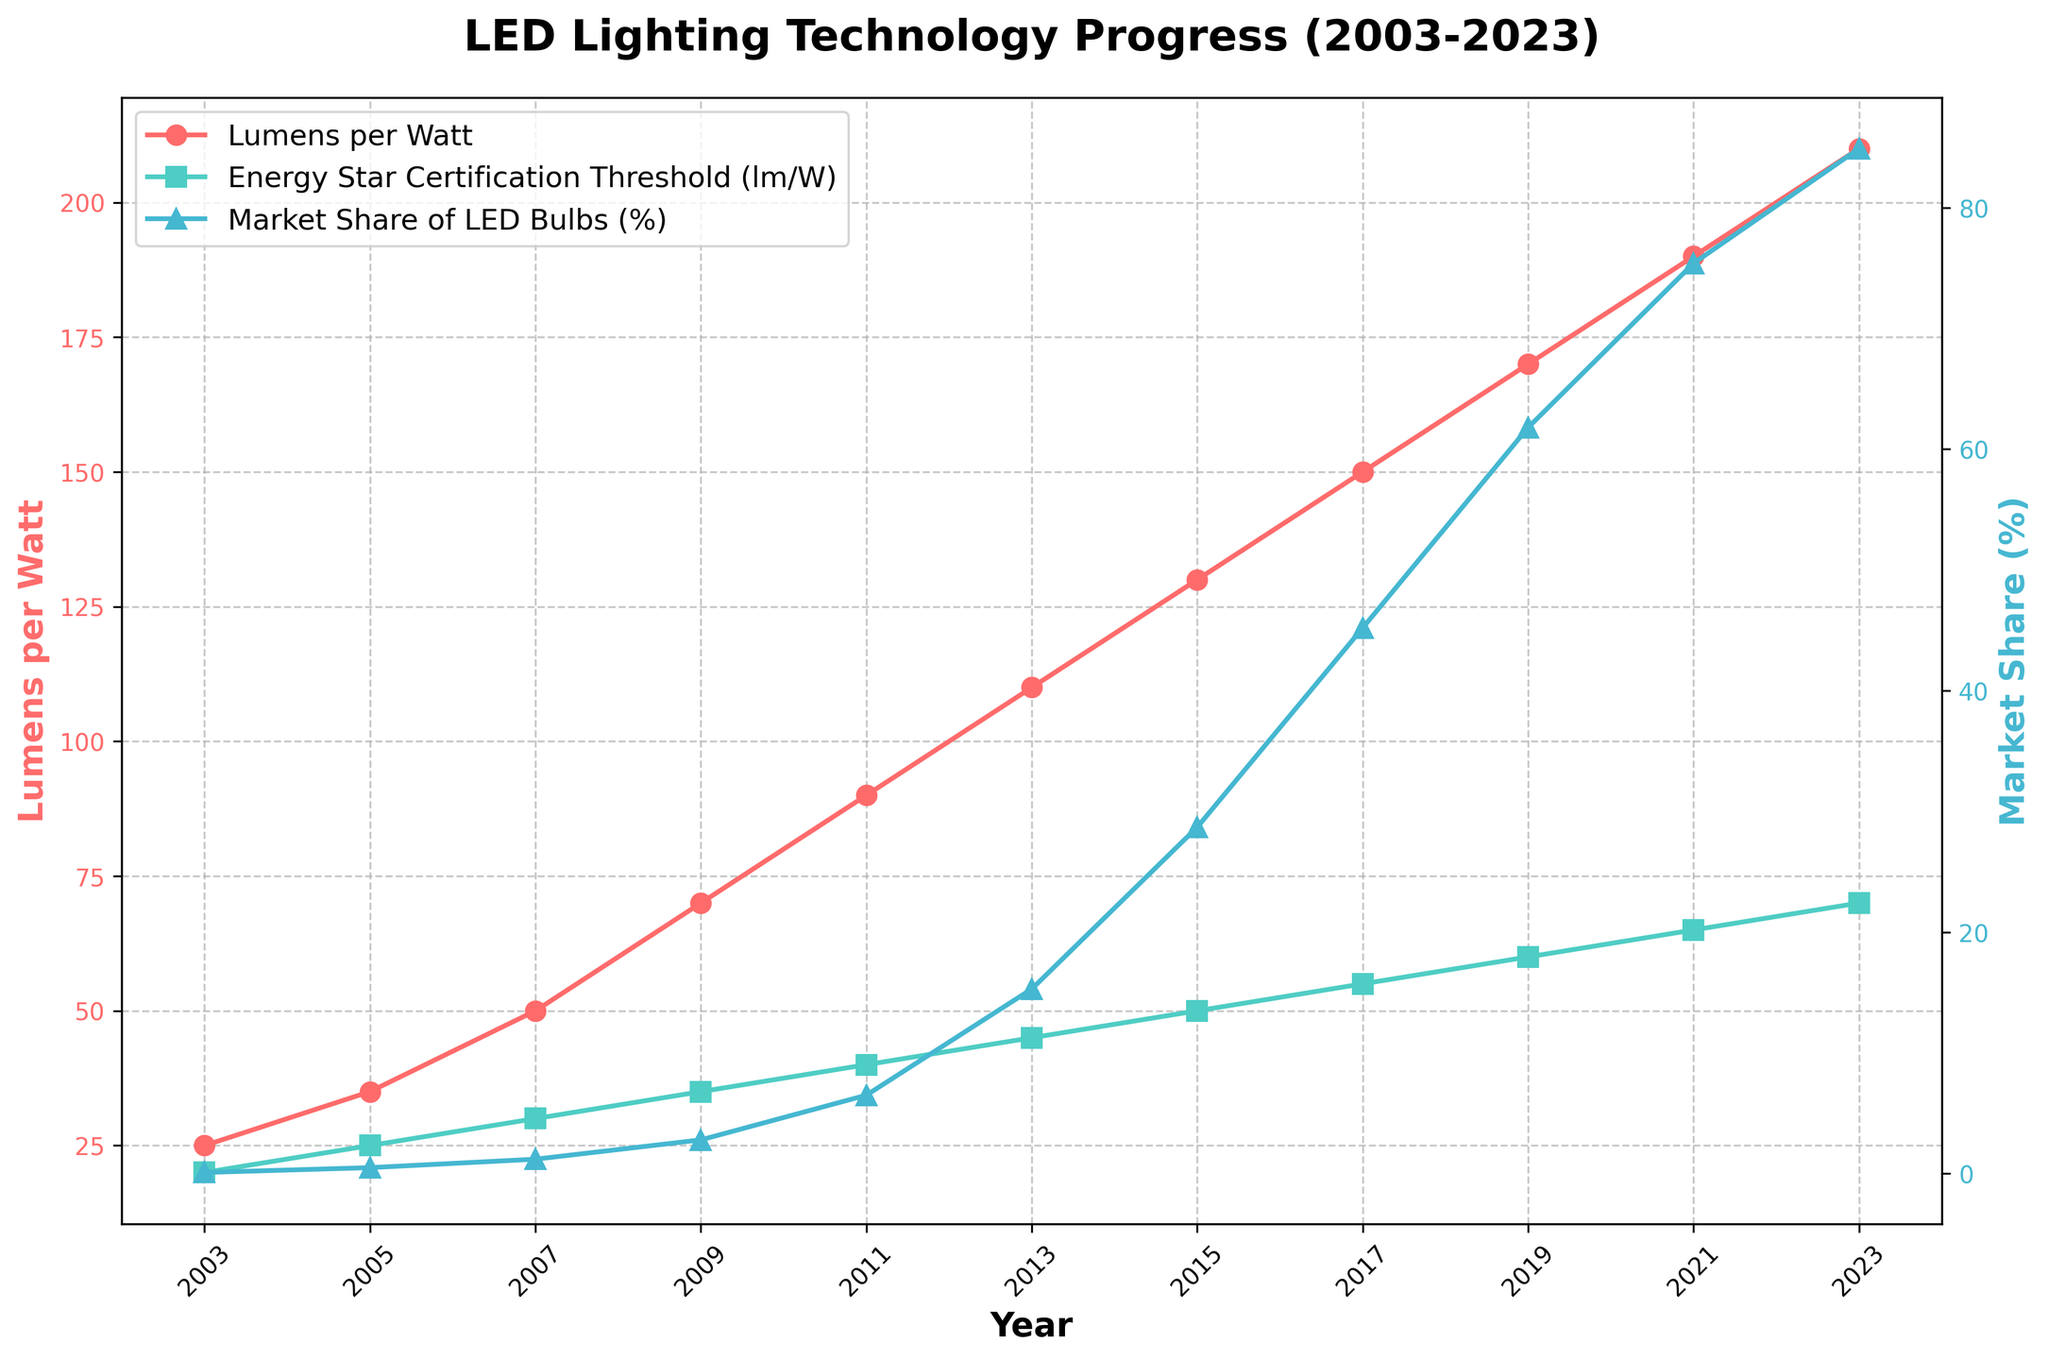What's the maximum value of Lumens per Watt, and in which year was it observed? First, look at the "Lumens per Watt" line (red line with circles) and find the peak value and its corresponding year. The peak value is 210 in 2023.
Answer: 210 in 2023 How has the Energy Star Certification Threshold changed from 2003 to 2023? Track the "Energy Star Certification Threshold (lm/W)" line (green line with squares) from 2003 to 2023. It increases from 20 lm/W to 70 lm/W.
Answer: Increased from 20 to 70 lm/W In which year did the Market Share of LED Bulbs exceed 50%? Observe the "Market Share of LED Bulbs (%)" line (blue line with triangles) and find the year when it first crosses 50%. It crossed 50% in 2017.
Answer: 2017 Compare the trend between Lumens per Watt and Market Share from 2009 to 2015. What do you observe? Track both "Lumens per Watt" and "Market Share" lines between 2009 and 2015. Both lines show an upward trend, with Lumens per Watt increasing from 70 to 130 and Market Share increasing from 2.8% to 28.7%.
Answer: Both increased What's the difference in Average Lifespan between 2003 and 2023? Look at the data points for "Average Lifespan (hours)" for 2003 and 2023. In 2003, it was 25,000 hours, and in 2023, it is 75,000 hours. The difference is 75,000 - 25,000 = 50,000 hours.
Answer: 50,000 hours Which had a steeper increase: Lumens per Watt from 2003 to 2013 or Market Share from 2009 to 2019? For Lumens per Watt, calculate the increase from 25 in 2003 to 110 in 2013, which is 110 - 25 = 85. For Market Share, calculate the increase from 2.8% in 2009 to 61.8% in 2019, which is 61.8 - 2.8 = 59. For Lumens per Watt, it's 85 over 10 years (8.5/year), and for Market Share, it's 59 over 10 years (5.9/year). Lumens per Watt had a steeper increase.
Answer: Lumens per Watt In which year did both Lumens per Watt and Energy Star Certification Threshold exceed 100 lm/W simultaneously? Identify when both lines (red for Lumens per Watt and green for Energy Star) are above 100 lm/W. In 2015, Lumens per Watt is 130, and Energy Star Certification Threshold is 50.
Answer: 2015 How did the Lumens per Watt change from 2015 to 2017, and what is the percentage increase? Lumens per Watt in 2015 was 130, and in 2017 it was 150. The increase is 150 - 130 = 20. The percentage increase is (20/130) * 100 ≈ 15.4%.
Answer: Approximately 15.4% Compare the Market Share of LED Bulbs in 2011 to 2021. Find the Market Share values for 2011 and 2021. In 2011, it was 6.5%, and in 2021, it was 75.4%. The increase is 75.4 - 6.5 = 68.9%.
Answer: Increased by 68.9% What pattern can you observe regarding the Lumens per Watt and Energy Star Certification Threshold over the given period? Observe both lines, each increasing steadily over the years. The Lumens per Watt consistently leads and increases at a higher rate than the Energy Star Certification Threshold.
Answer: Steady increase with Lumens per Watt leading and growing faster 